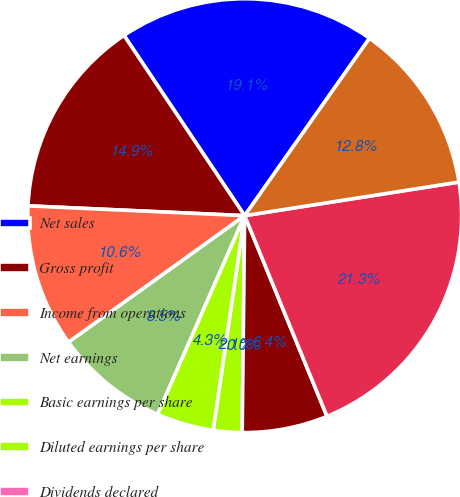<chart> <loc_0><loc_0><loc_500><loc_500><pie_chart><fcel>Net sales<fcel>Gross profit<fcel>Income from operations<fcel>Net earnings<fcel>Basic earnings per share<fcel>Diluted earnings per share<fcel>Dividends declared<fcel>Working capital<fcel>Total assets<fcel>Long-term debt less current<nl><fcel>19.15%<fcel>14.89%<fcel>10.64%<fcel>8.51%<fcel>4.26%<fcel>2.13%<fcel>0.0%<fcel>6.38%<fcel>21.28%<fcel>12.77%<nl></chart> 